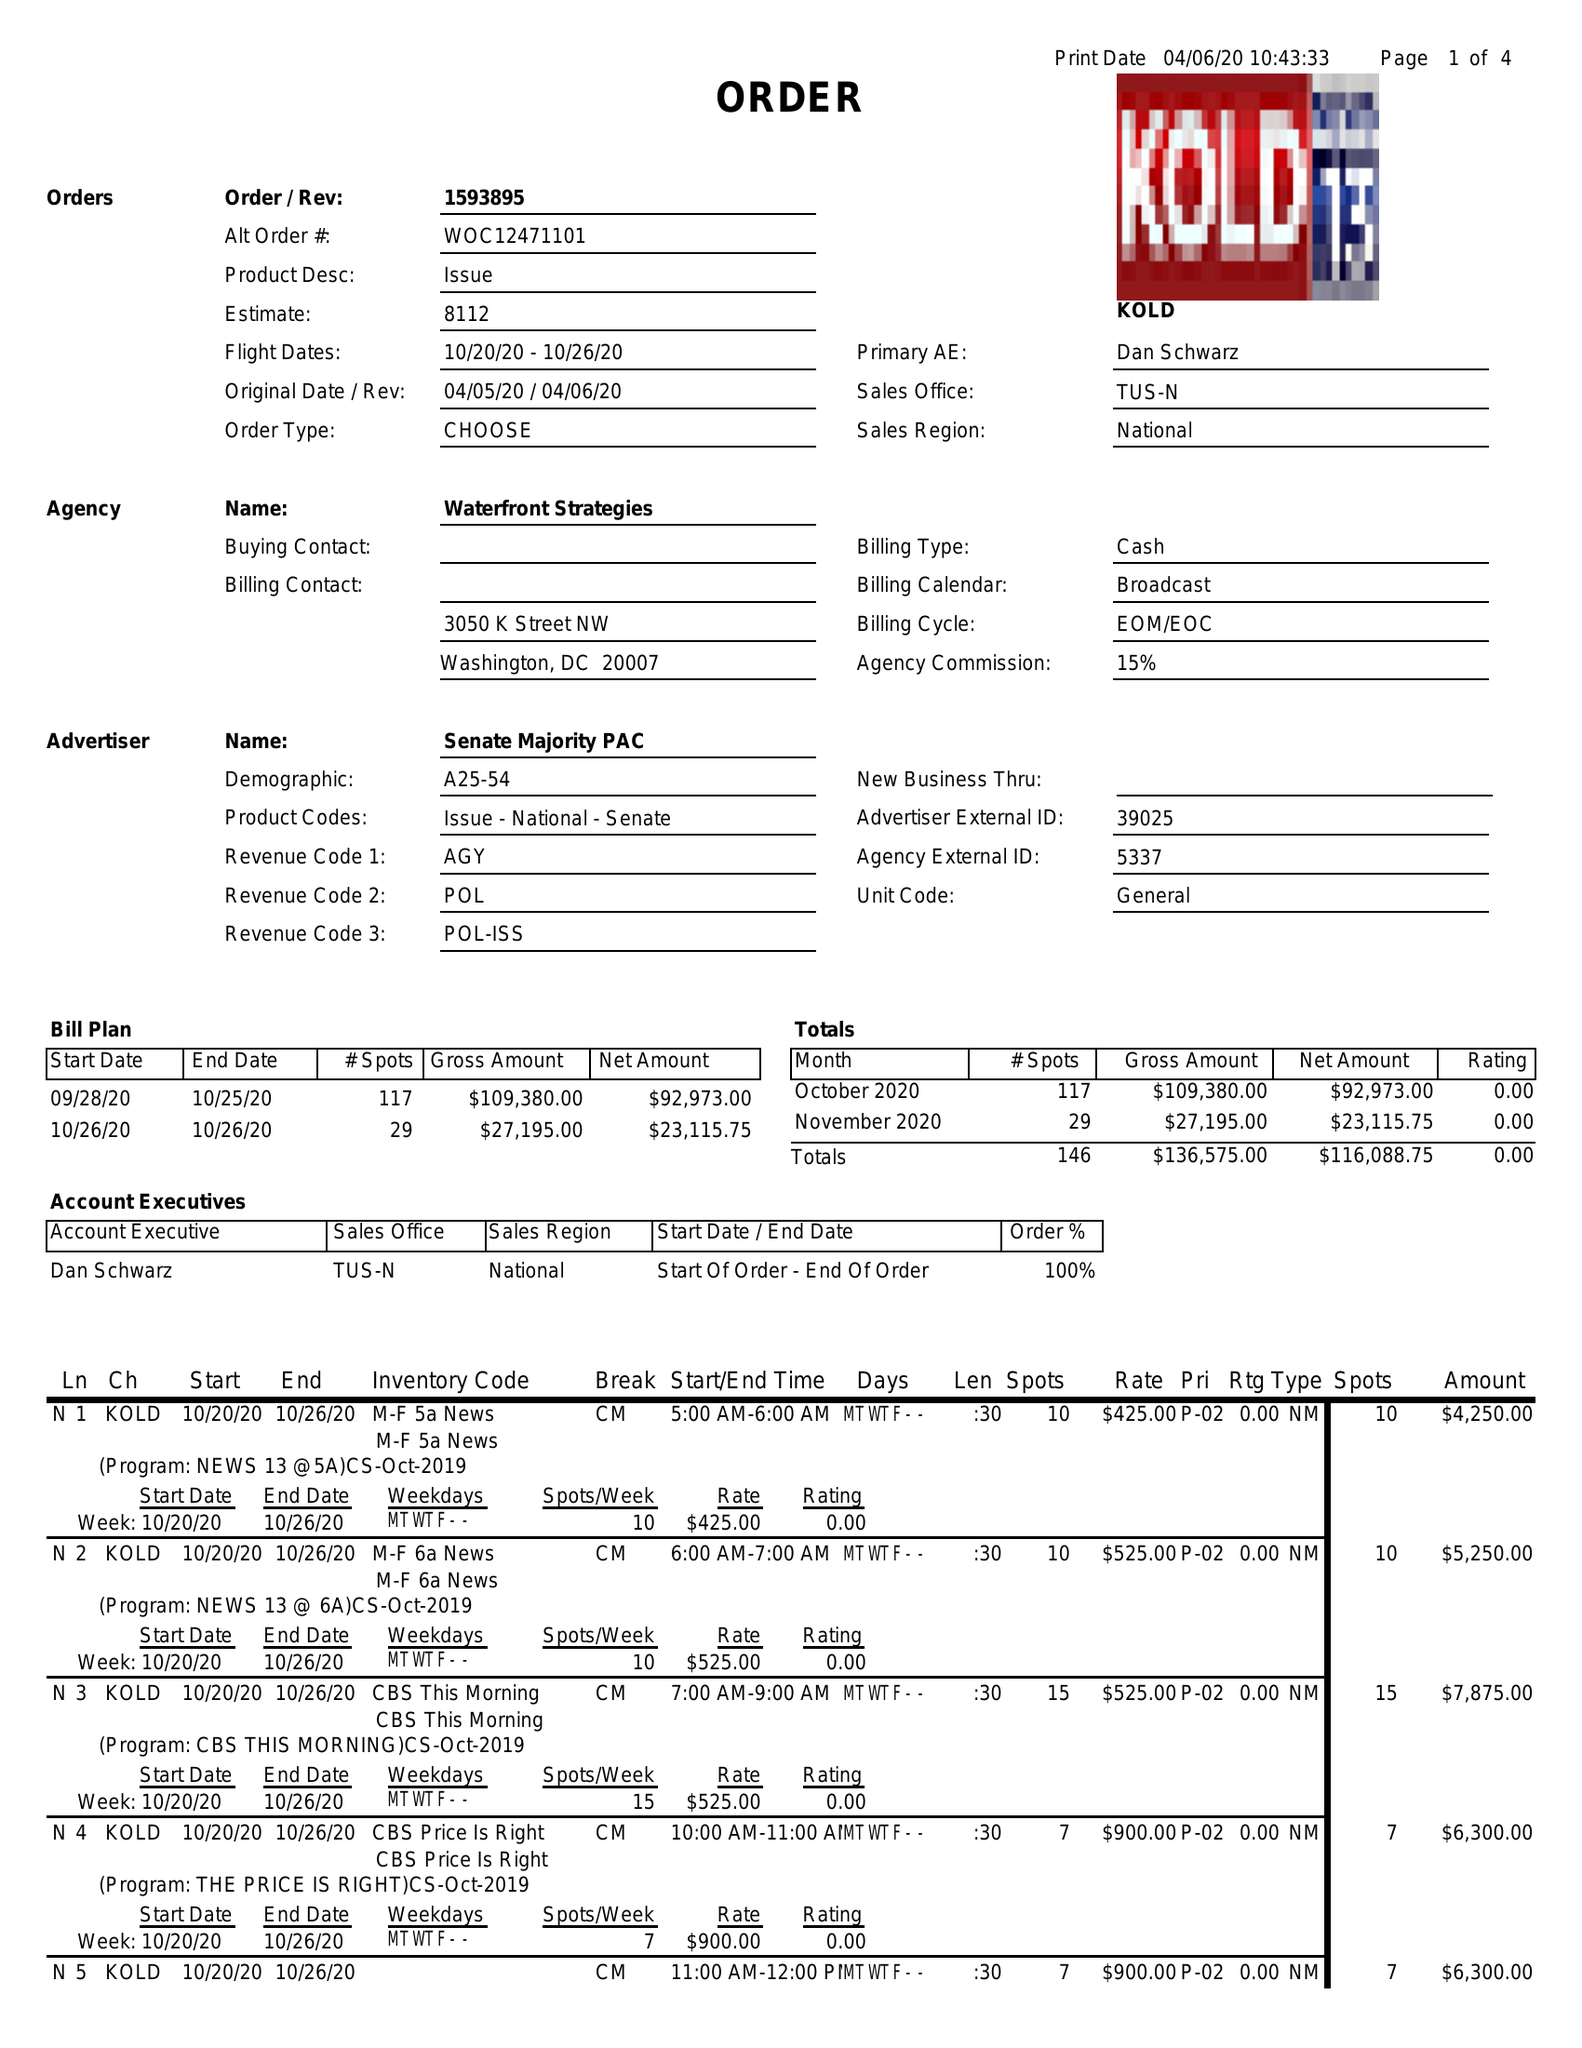What is the value for the flight_to?
Answer the question using a single word or phrase. 10/26/20 